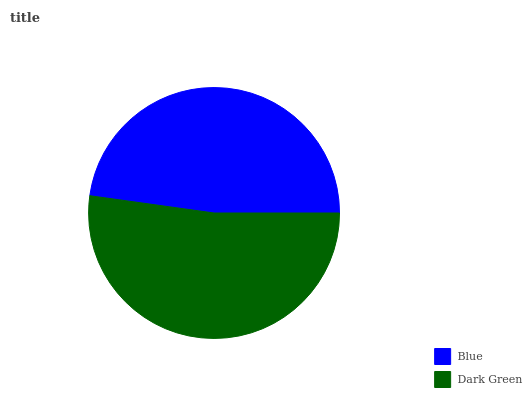Is Blue the minimum?
Answer yes or no. Yes. Is Dark Green the maximum?
Answer yes or no. Yes. Is Dark Green the minimum?
Answer yes or no. No. Is Dark Green greater than Blue?
Answer yes or no. Yes. Is Blue less than Dark Green?
Answer yes or no. Yes. Is Blue greater than Dark Green?
Answer yes or no. No. Is Dark Green less than Blue?
Answer yes or no. No. Is Dark Green the high median?
Answer yes or no. Yes. Is Blue the low median?
Answer yes or no. Yes. Is Blue the high median?
Answer yes or no. No. Is Dark Green the low median?
Answer yes or no. No. 